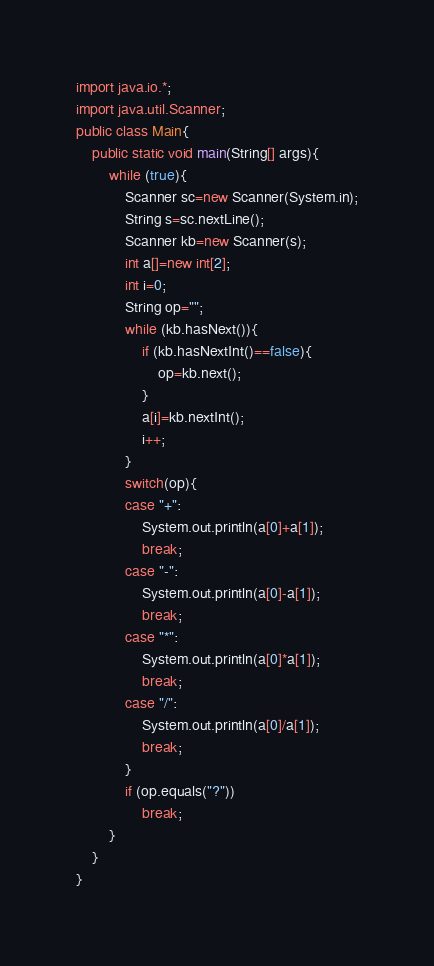Convert code to text. <code><loc_0><loc_0><loc_500><loc_500><_Java_>import java.io.*;
import java.util.Scanner;
public class Main{
    public static void main(String[] args){
        while (true){
            Scanner sc=new Scanner(System.in);
            String s=sc.nextLine();
            Scanner kb=new Scanner(s);
            int a[]=new int[2];
            int i=0;
            String op="";
            while (kb.hasNext()){
                if (kb.hasNextInt()==false){
                    op=kb.next();
                }
                a[i]=kb.nextInt();
                i++;
            }
            switch(op){
            case "+":
                System.out.println(a[0]+a[1]);
                break;
            case "-":
                System.out.println(a[0]-a[1]);
                break;
            case "*":
                System.out.println(a[0]*a[1]);
                break;
            case "/":
                System.out.println(a[0]/a[1]);
                break;
            }
            if (op.equals("?"))
                break;
        }
    }
}</code> 